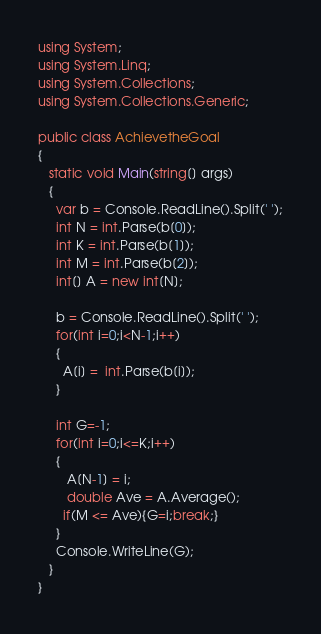<code> <loc_0><loc_0><loc_500><loc_500><_C#_>using System;
using System.Linq;
using System.Collections;
using System.Collections.Generic;

public class AchievetheGoal
{
   static void Main(string[] args) 
   {
     var b = Console.ReadLine().Split(' ');
     int N = int.Parse(b[0]);
     int K = int.Parse(b[1]);
     int M = int.Parse(b[2]);
     int[] A = new int[N];
	
     b = Console.ReadLine().Split(' ');
     for(int i=0;i<N-1;i++)
     {
       A[i] =  int.Parse(b[i]);
     }
     
     int G=-1;
     for(int i=0;i<=K;i++)
     {
     	A[N-1] = i;
        double Ave = A.Average();
       if(M <= Ave){G=i;break;}
     }     
     Console.WriteLine(G);
   }  
}</code> 